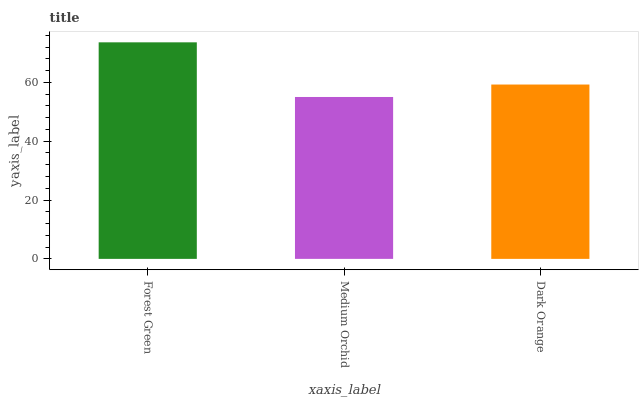Is Dark Orange the minimum?
Answer yes or no. No. Is Dark Orange the maximum?
Answer yes or no. No. Is Dark Orange greater than Medium Orchid?
Answer yes or no. Yes. Is Medium Orchid less than Dark Orange?
Answer yes or no. Yes. Is Medium Orchid greater than Dark Orange?
Answer yes or no. No. Is Dark Orange less than Medium Orchid?
Answer yes or no. No. Is Dark Orange the high median?
Answer yes or no. Yes. Is Dark Orange the low median?
Answer yes or no. Yes. Is Medium Orchid the high median?
Answer yes or no. No. Is Forest Green the low median?
Answer yes or no. No. 